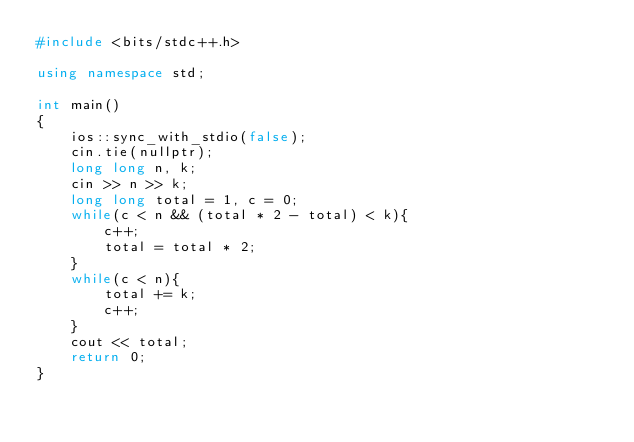Convert code to text. <code><loc_0><loc_0><loc_500><loc_500><_C++_>#include <bits/stdc++.h>

using namespace std;

int main()
{
    ios::sync_with_stdio(false);
    cin.tie(nullptr);
    long long n, k;
    cin >> n >> k;
    long long total = 1, c = 0;
    while(c < n && (total * 2 - total) < k){
        c++;
        total = total * 2;
    }
    while(c < n){
        total += k;
        c++;
    }
    cout << total;
    return 0;
}
</code> 